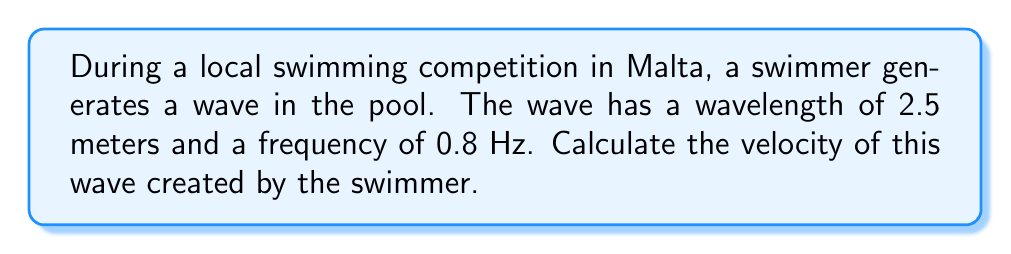Can you solve this math problem? To solve this problem, we'll use the wave equation that relates velocity, wavelength, and frequency:

$$v = \lambda f$$

Where:
$v$ = wave velocity (m/s)
$\lambda$ = wavelength (m)
$f$ = frequency (Hz)

Given:
$\lambda = 2.5$ m
$f = 0.8$ Hz

Step 1: Substitute the known values into the equation:
$$v = 2.5 \text{ m} \times 0.8 \text{ Hz}$$

Step 2: Multiply the values:
$$v = 2 \text{ m/s}$$

Therefore, the velocity of the wave created by the swimmer is 2 m/s.
Answer: $2 \text{ m/s}$ 